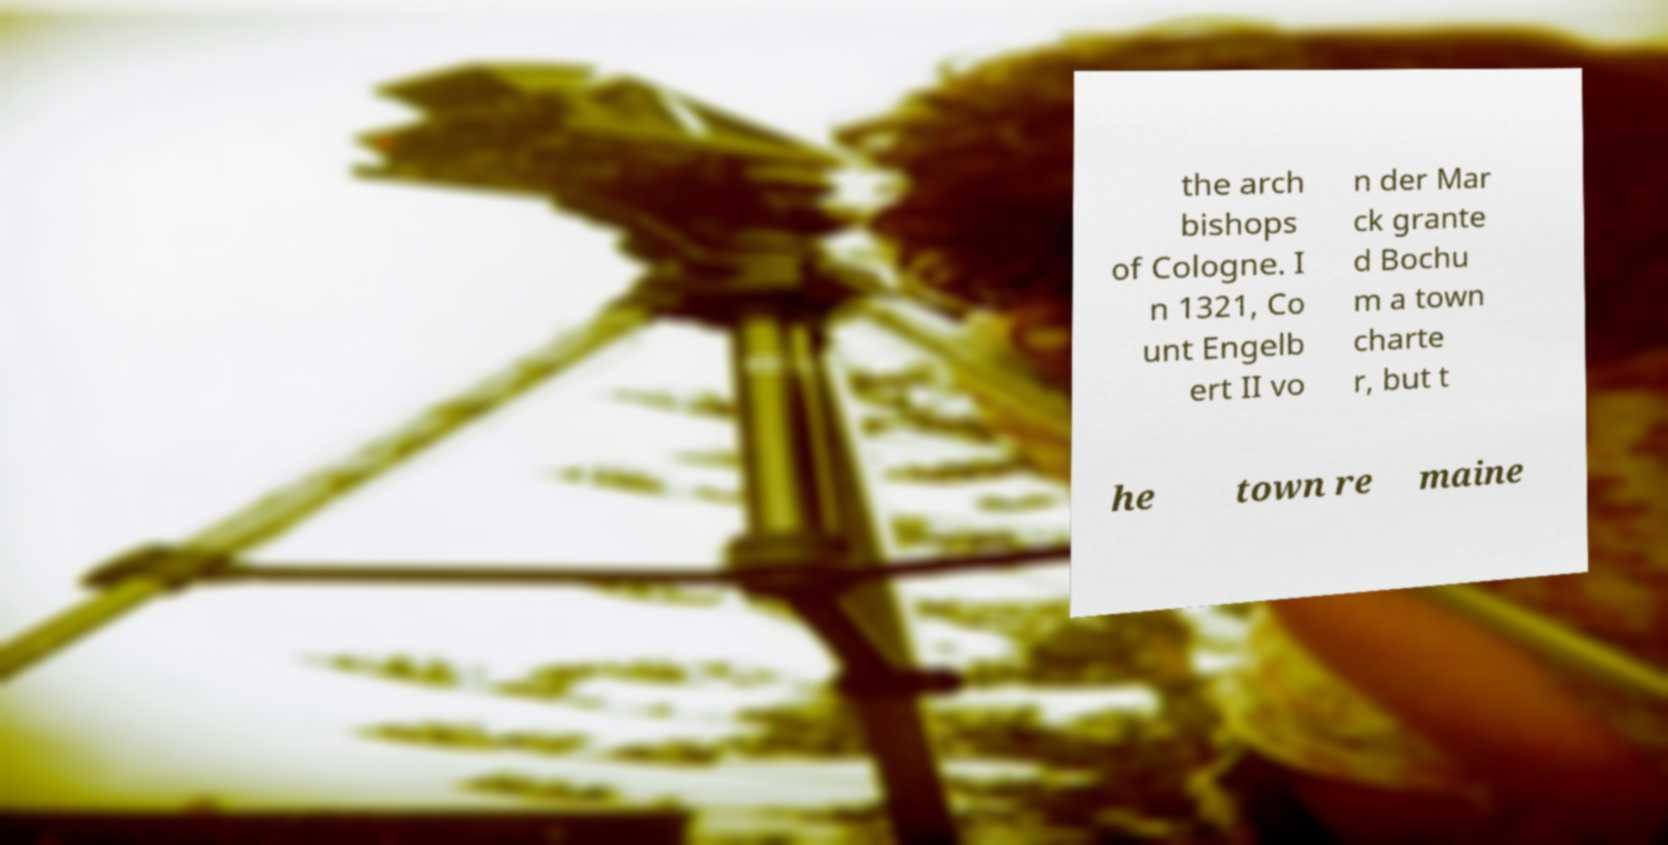Could you extract and type out the text from this image? the arch bishops of Cologne. I n 1321, Co unt Engelb ert II vo n der Mar ck grante d Bochu m a town charte r, but t he town re maine 